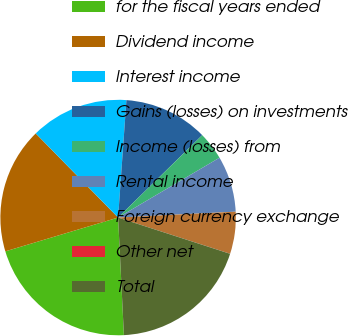Convert chart to OTSL. <chart><loc_0><loc_0><loc_500><loc_500><pie_chart><fcel>for the fiscal years ended<fcel>Dividend income<fcel>Interest income<fcel>Gains (losses) on investments<fcel>Income (losses) from<fcel>Rental income<fcel>Foreign currency exchange<fcel>Other net<fcel>Total<nl><fcel>21.15%<fcel>17.3%<fcel>13.46%<fcel>11.54%<fcel>3.85%<fcel>7.69%<fcel>5.77%<fcel>0.01%<fcel>19.23%<nl></chart> 